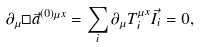<formula> <loc_0><loc_0><loc_500><loc_500>\partial _ { \mu } \Box \vec { a } ^ { ( 0 ) \mu x } = \sum _ { i } \partial _ { \mu } T _ { i } ^ { \mu x } \vec { I } _ { i } = 0 ,</formula> 